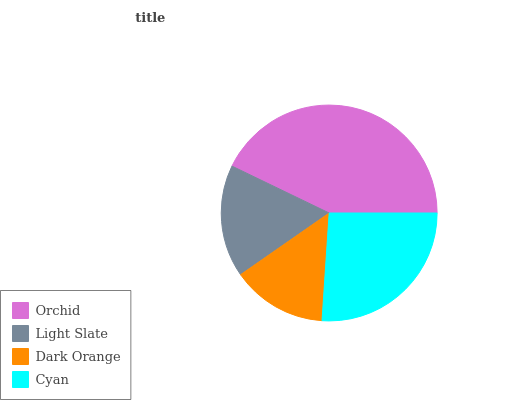Is Dark Orange the minimum?
Answer yes or no. Yes. Is Orchid the maximum?
Answer yes or no. Yes. Is Light Slate the minimum?
Answer yes or no. No. Is Light Slate the maximum?
Answer yes or no. No. Is Orchid greater than Light Slate?
Answer yes or no. Yes. Is Light Slate less than Orchid?
Answer yes or no. Yes. Is Light Slate greater than Orchid?
Answer yes or no. No. Is Orchid less than Light Slate?
Answer yes or no. No. Is Cyan the high median?
Answer yes or no. Yes. Is Light Slate the low median?
Answer yes or no. Yes. Is Orchid the high median?
Answer yes or no. No. Is Dark Orange the low median?
Answer yes or no. No. 